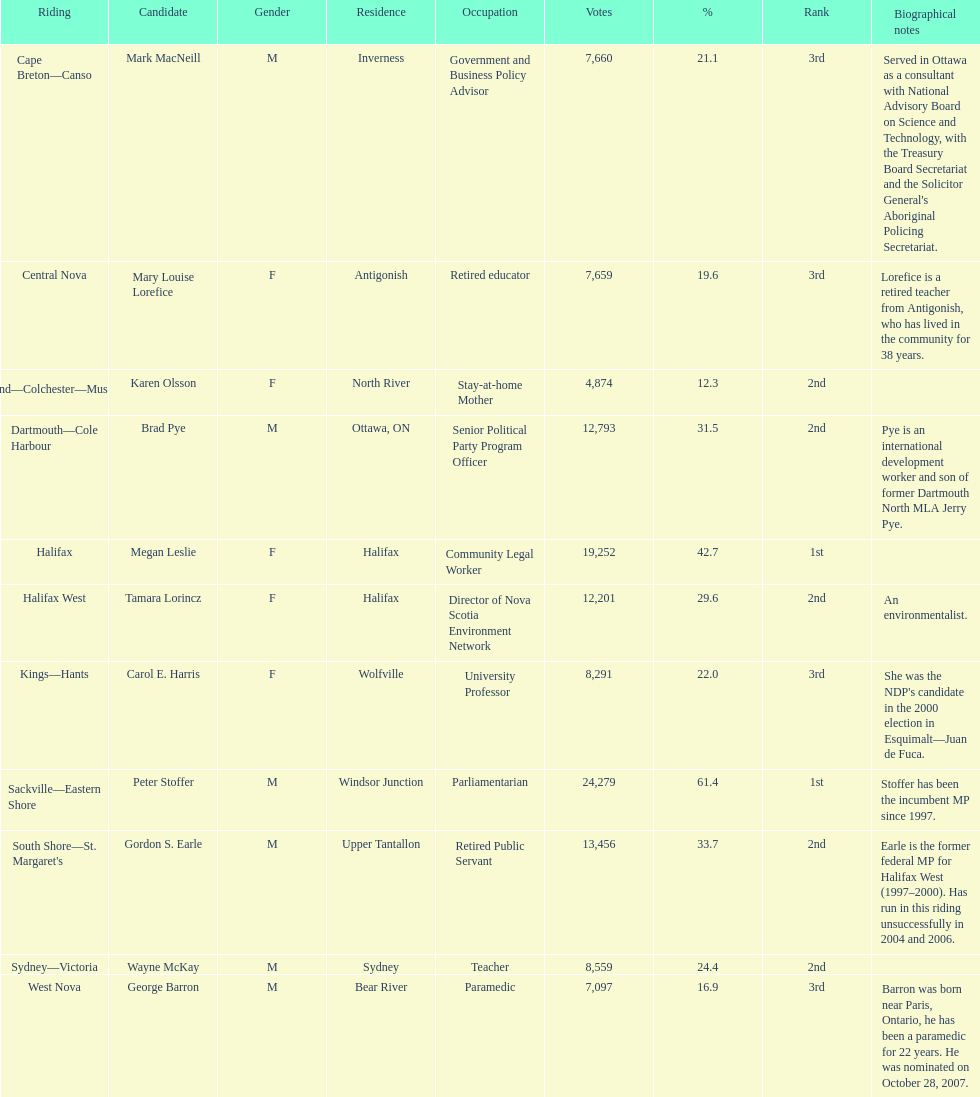Which candidate obtained a higher vote count, macneill or olsson? Mark MacNeill. 